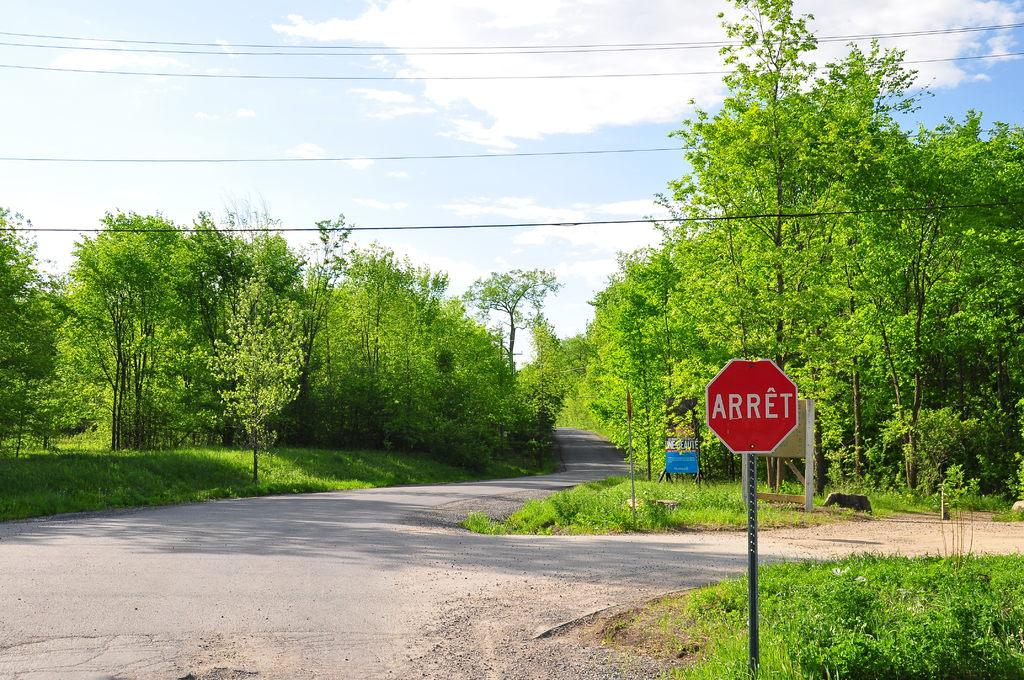What is the main feature of the image? There is a road in the image. What can be seen alongside the road? Trees and grass are visible along the sides of the road. Are there any signs or markers along the road? Yes, sign boards are present along the sides of the road. What type of verse can be heard being recited by the quince in the image? There is no quince or any recitation of verse present in the image. 